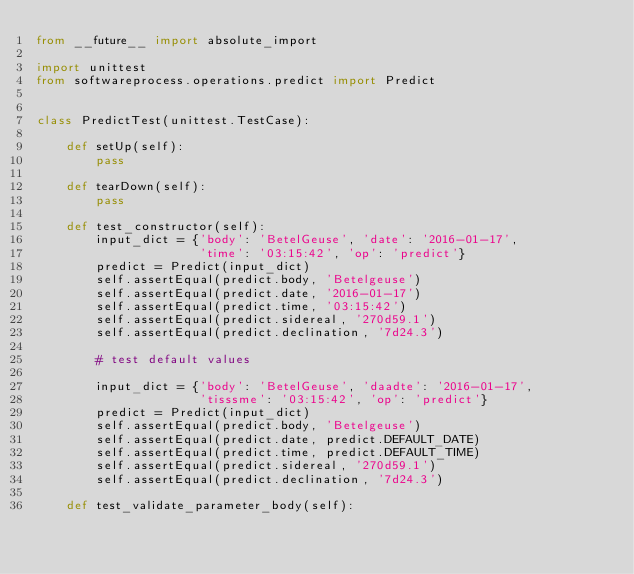<code> <loc_0><loc_0><loc_500><loc_500><_Python_>from __future__ import absolute_import

import unittest
from softwareprocess.operations.predict import Predict


class PredictTest(unittest.TestCase):
    
    def setUp(self):
        pass
    
    def tearDown(self):
        pass
    
    def test_constructor(self):
        input_dict = {'body': 'BetelGeuse', 'date': '2016-01-17',
                      'time': '03:15:42', 'op': 'predict'}
        predict = Predict(input_dict)
        self.assertEqual(predict.body, 'Betelgeuse')
        self.assertEqual(predict.date, '2016-01-17')
        self.assertEqual(predict.time, '03:15:42')
        self.assertEqual(predict.sidereal, '270d59.1')
        self.assertEqual(predict.declination, '7d24.3')
        
        # test default values
        
        input_dict = {'body': 'BetelGeuse', 'daadte': '2016-01-17',
                      'tisssme': '03:15:42', 'op': 'predict'}
        predict = Predict(input_dict)
        self.assertEqual(predict.body, 'Betelgeuse')
        self.assertEqual(predict.date, predict.DEFAULT_DATE)
        self.assertEqual(predict.time, predict.DEFAULT_TIME)
        self.assertEqual(predict.sidereal, '270d59.1')
        self.assertEqual(predict.declination, '7d24.3')
    
    def test_validate_parameter_body(self):</code> 